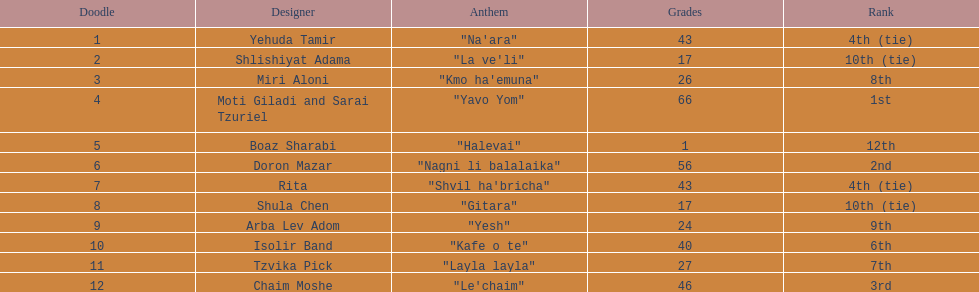What is the total amount of ties in this competition? 2. 